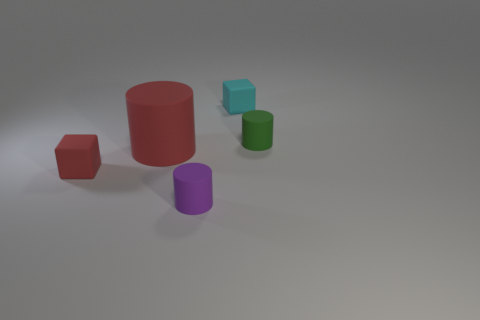There is a red object to the right of the cube in front of the small matte block right of the tiny purple rubber object; what is its size?
Keep it short and to the point. Large. What is the size of the red cylinder that is the same material as the cyan block?
Keep it short and to the point. Large. The small rubber object that is both in front of the cyan matte thing and right of the purple object is what color?
Ensure brevity in your answer.  Green. Do the object that is behind the green rubber thing and the thing on the left side of the big thing have the same shape?
Provide a succinct answer. Yes. What number of objects are either objects on the left side of the purple cylinder or tiny blocks?
Your answer should be very brief. 3. Is the number of cyan matte objects left of the big object the same as the number of tiny green rubber things?
Make the answer very short. No. Is the size of the purple rubber cylinder the same as the green matte thing?
Your response must be concise. Yes. What is the color of the other cube that is the same size as the cyan cube?
Your response must be concise. Red. Do the purple cylinder and the matte cube on the left side of the small cyan rubber object have the same size?
Your answer should be compact. Yes. What number of tiny matte objects are the same color as the large thing?
Give a very brief answer. 1. 